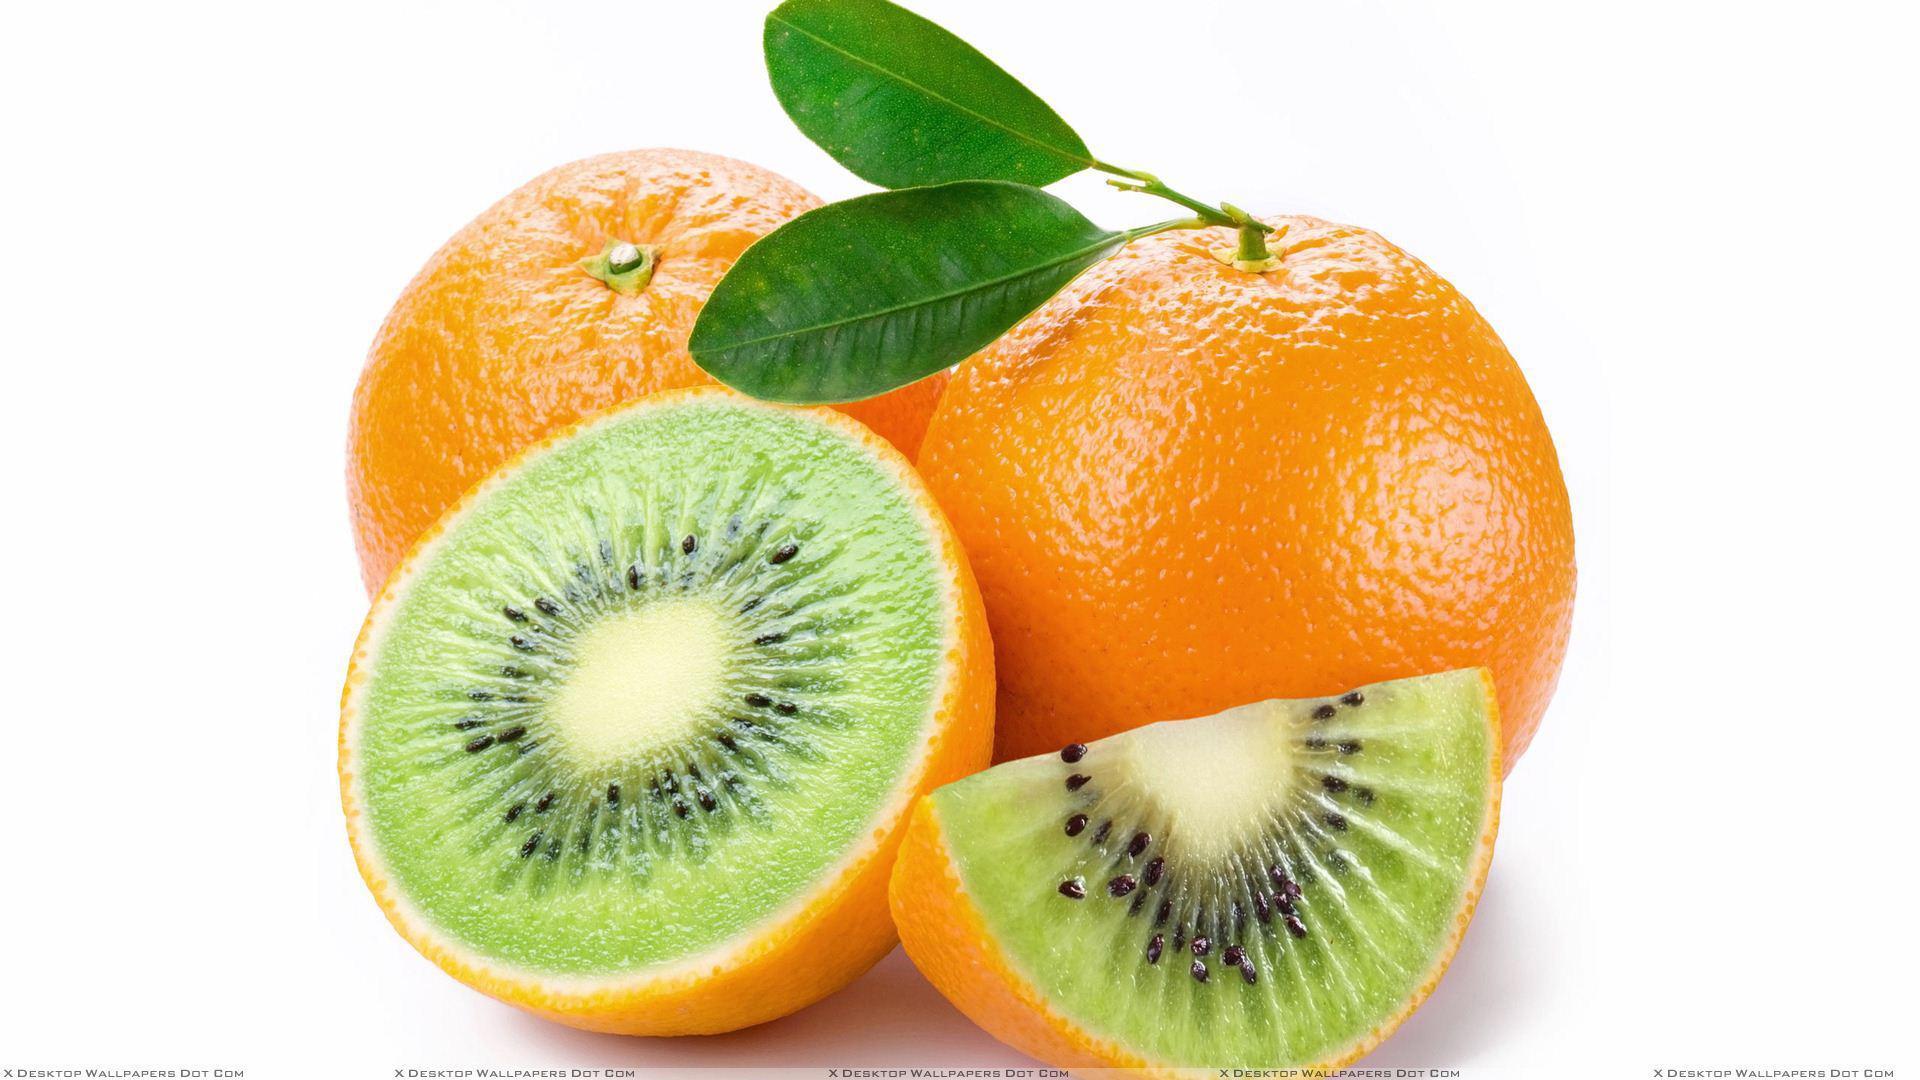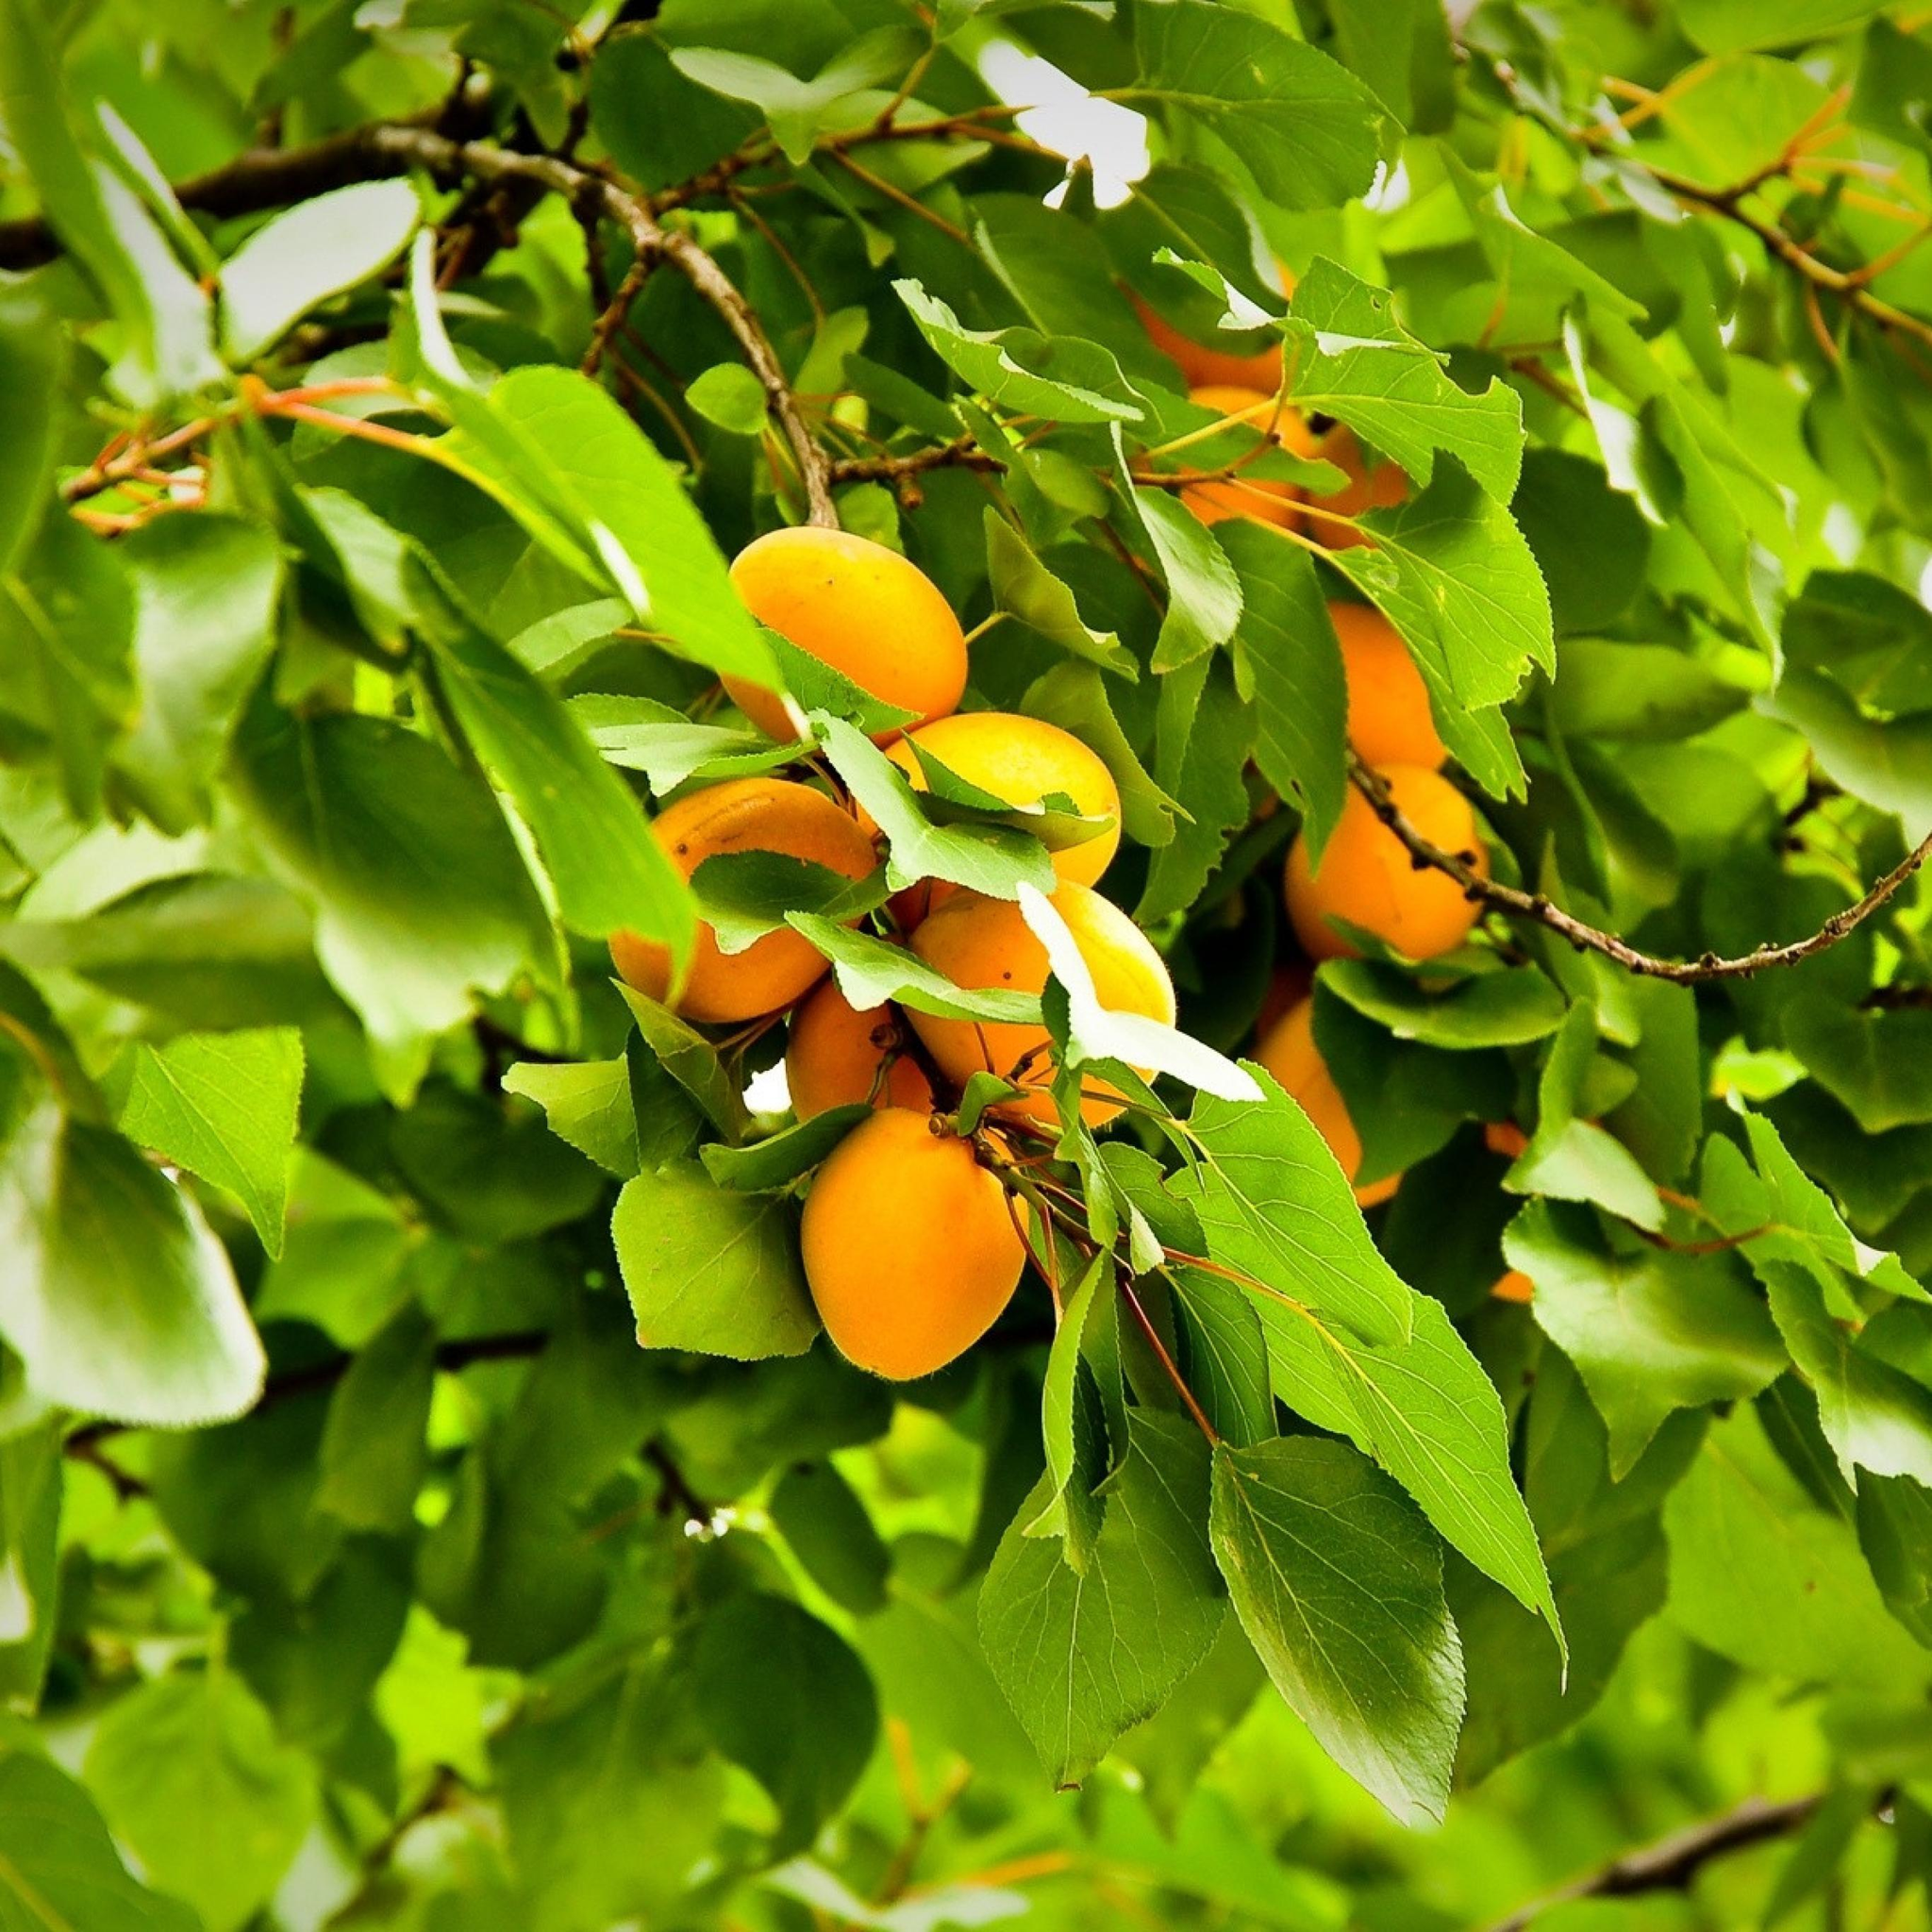The first image is the image on the left, the second image is the image on the right. Considering the images on both sides, is "The image on the left shows both cut fruit and uncut fruit." valid? Answer yes or no. Yes. 